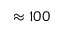Convert formula to latex. <formula><loc_0><loc_0><loc_500><loc_500>\approx 1 0 0</formula> 